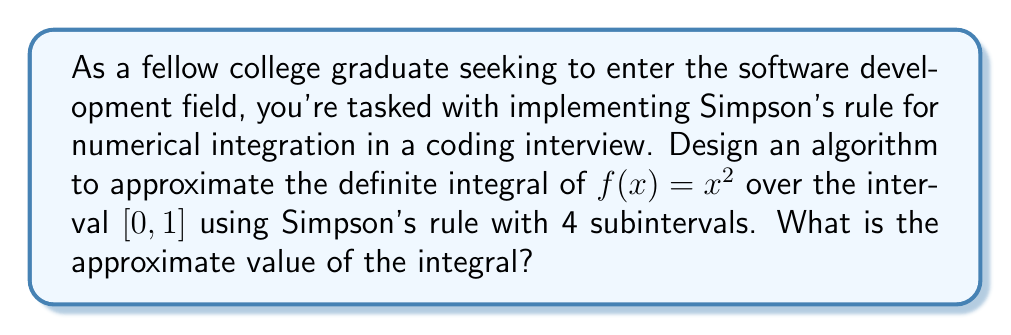Give your solution to this math problem. Let's approach this step-by-step:

1) Simpson's rule for n subintervals is given by:

   $$\int_a^b f(x)dx \approx \frac{h}{3}[f(x_0) + 4f(x_1) + 2f(x_2) + 4f(x_3) + ... + 2f(x_{n-2}) + 4f(x_{n-1}) + f(x_n)]$$

   where $h = \frac{b-a}{n}$ and $x_i = a + ih$ for $i = 0, 1, ..., n$

2) In this case, $a = 0$, $b = 1$, $n = 4$, and $f(x) = x^2$

3) Calculate $h$:
   $h = \frac{1-0}{4} = 0.25$

4) Calculate the $x_i$ values:
   $x_0 = 0$
   $x_1 = 0.25$
   $x_2 = 0.5$
   $x_3 = 0.75$
   $x_4 = 1$

5) Calculate the $f(x_i)$ values:
   $f(x_0) = 0^2 = 0$
   $f(x_1) = 0.25^2 = 0.0625$
   $f(x_2) = 0.5^2 = 0.25$
   $f(x_3) = 0.75^2 = 0.5625$
   $f(x_4) = 1^2 = 1$

6) Apply Simpson's rule:

   $$\int_0^1 x^2 dx \approx \frac{0.25}{3}[0 + 4(0.0625) + 2(0.25) + 4(0.5625) + 1]$$

7) Simplify:
   $$\approx \frac{0.25}{3}[0 + 0.25 + 0.5 + 2.25 + 1]$$
   $$\approx \frac{0.25}{3}[4]$$
   $$\approx \frac{1}{3}$$

Therefore, the approximate value of the integral using Simpson's rule with 4 subintervals is $\frac{1}{3}$.
Answer: $\frac{1}{3}$ 